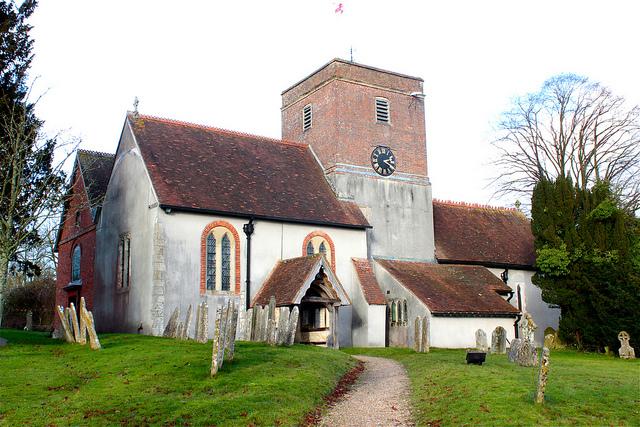How many windows are shown on the front of the house?
Concise answer only. 4. Is the church white or eggshell colored?
Answer briefly. White. What time is showing on the clock?
Quick response, please. 2:20. 